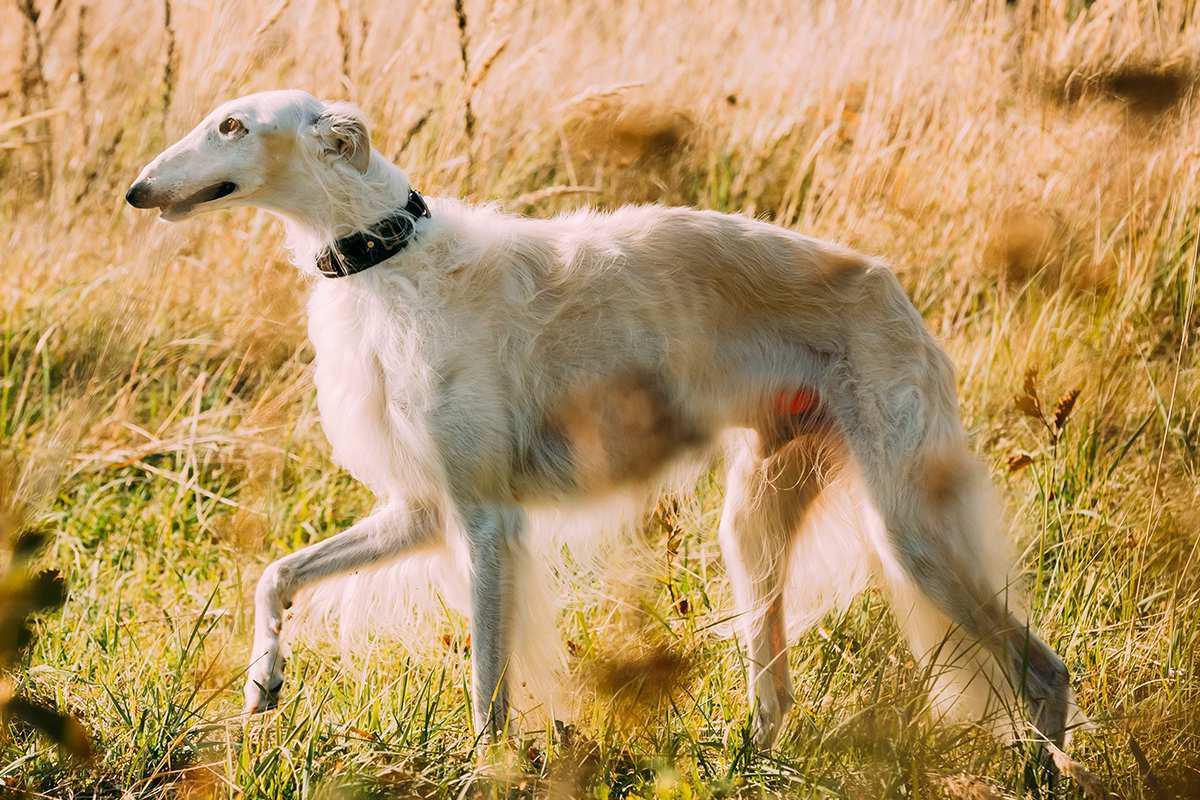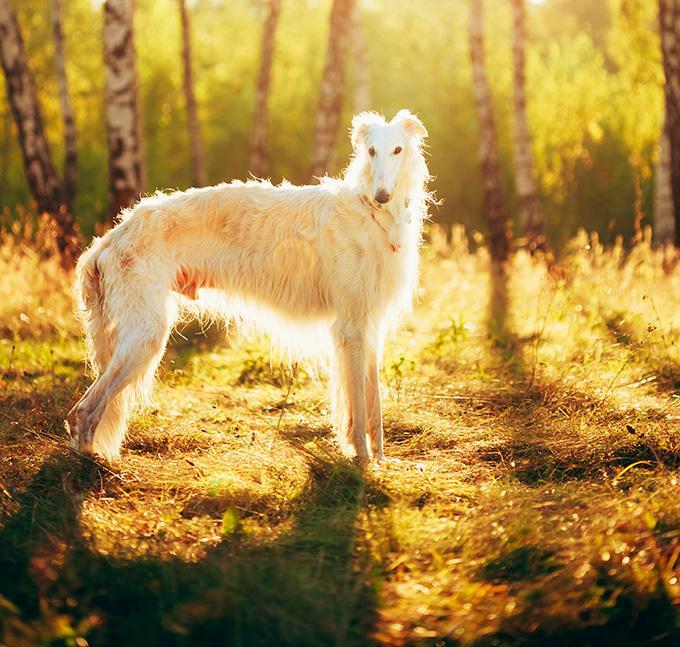The first image is the image on the left, the second image is the image on the right. Evaluate the accuracy of this statement regarding the images: "At least one dog wears a collar with no leash.". Is it true? Answer yes or no. Yes. 